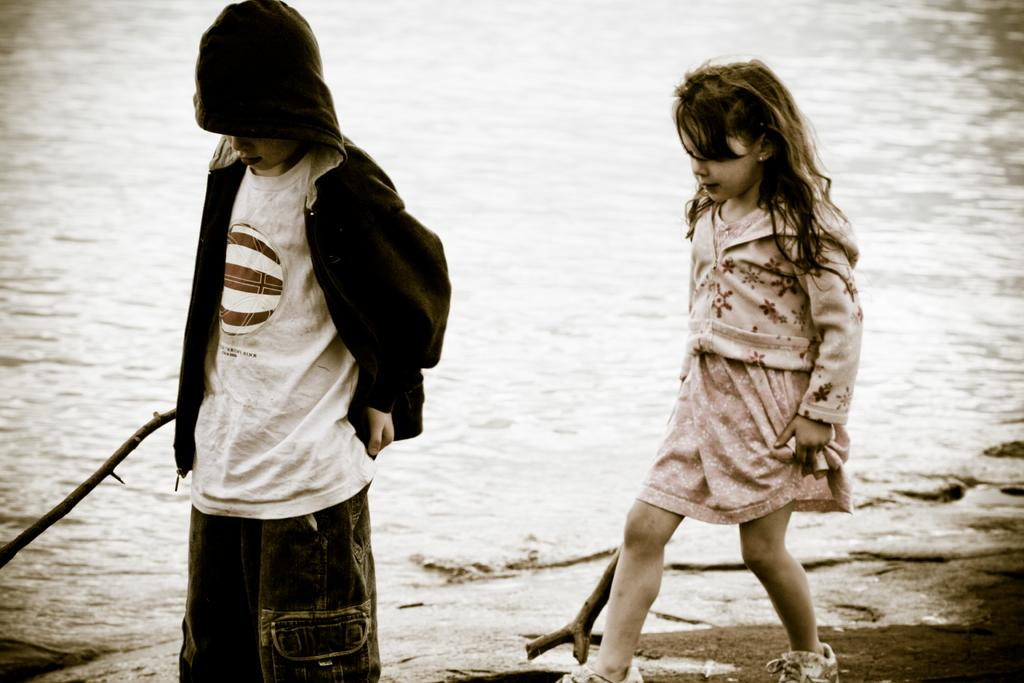How many people are in the image? There are two people in the image. What are the people holding in their hands? The people are holding wooden sticks. What can be seen behind the people in the image? There is water visible behind the people. What type of work are the people doing with the wooden sticks in the image? There is no indication of work being done with the wooden sticks in the image. 